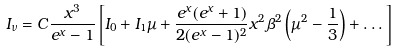Convert formula to latex. <formula><loc_0><loc_0><loc_500><loc_500>I _ { \nu } = C \frac { x ^ { 3 } } { e ^ { x } - 1 } \left [ I _ { 0 } + I _ { 1 } \mu + \frac { e ^ { x } ( e ^ { x } + 1 ) } { 2 ( e ^ { x } - 1 ) ^ { 2 } } x ^ { 2 } \beta ^ { 2 } \left ( \mu ^ { 2 } - \frac { 1 } { 3 } \right ) + \dots \right ] \,</formula> 